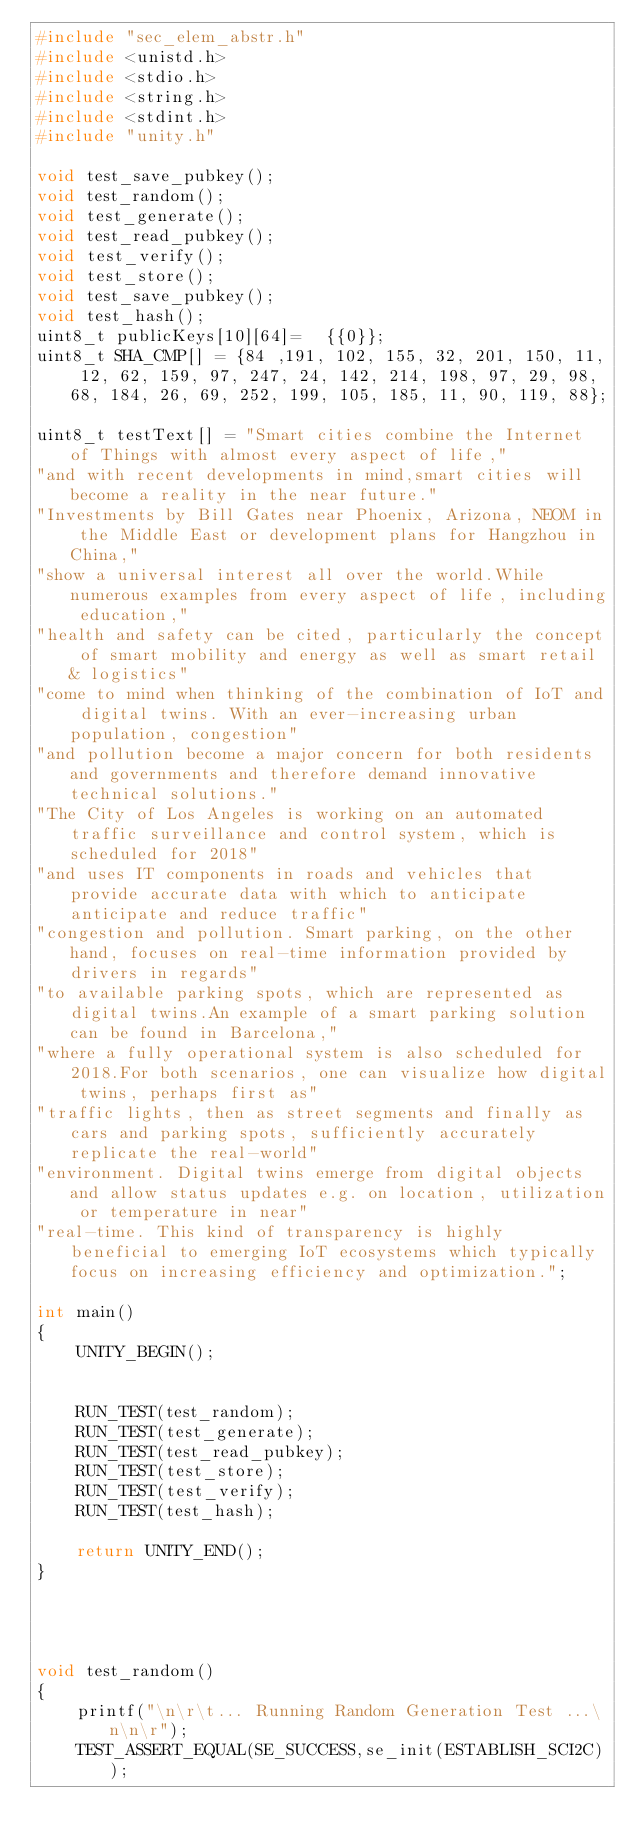<code> <loc_0><loc_0><loc_500><loc_500><_C_>#include "sec_elem_abstr.h"
#include <unistd.h>
#include <stdio.h>
#include <string.h>
#include <stdint.h>
#include "unity.h"

void test_save_pubkey();
void test_random();
void test_generate();
void test_read_pubkey();
void test_verify();
void test_store();
void test_save_pubkey();
void test_hash();
uint8_t publicKeys[10][64]=  {{0}};
uint8_t SHA_CMP[] = {84 ,191, 102, 155, 32, 201, 150, 11, 12, 62, 159, 97, 247, 24, 142, 214, 198, 97, 29, 98, 68, 184, 26, 69, 252, 199, 105, 185, 11, 90, 119, 88};

uint8_t testText[] = "Smart cities combine the Internet of Things with almost every aspect of life,"
"and with recent developments in mind,smart cities will become a reality in the near future."
"Investments by Bill Gates near Phoenix, Arizona, NEOM in the Middle East or development plans for Hangzhou in China,"
"show a universal interest all over the world.While numerous examples from every aspect of life, including education,"
"health and safety can be cited, particularly the concept of smart mobility and energy as well as smart retail & logistics"
"come to mind when thinking of the combination of IoT and digital twins. With an ever-increasing urban population, congestion"
"and pollution become a major concern for both residents and governments and therefore demand innovative technical solutions."
"The City of Los Angeles is working on an automated traffic surveillance and control system, which is scheduled for 2018"
"and uses IT components in roads and vehicles that provide accurate data with which to anticipate anticipate and reduce traffic"
"congestion and pollution. Smart parking, on the other hand, focuses on real-time information provided by drivers in regards"
"to available parking spots, which are represented as digital twins.An example of a smart parking solution can be found in Barcelona,"
"where a fully operational system is also scheduled for 2018.For both scenarios, one can visualize how digital twins, perhaps first as"
"traffic lights, then as street segments and finally as cars and parking spots, sufficiently accurately replicate the real-world"
"environment. Digital twins emerge from digital objects and allow status updates e.g. on location, utilization or temperature in near"
"real-time. This kind of transparency is highly beneficial to emerging IoT ecosystems which typically focus on increasing efficiency and optimization.";

int main()
{
    UNITY_BEGIN();


    RUN_TEST(test_random);
    RUN_TEST(test_generate);
    RUN_TEST(test_read_pubkey);
    RUN_TEST(test_store);
    RUN_TEST(test_verify);
    RUN_TEST(test_hash);

    return UNITY_END();
}




void test_random()
{
    printf("\n\r\t... Running Random Generation Test ...\n\n\r");
    TEST_ASSERT_EQUAL(SE_SUCCESS,se_init(ESTABLISH_SCI2C));</code> 